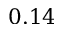<formula> <loc_0><loc_0><loc_500><loc_500>0 . 1 4</formula> 